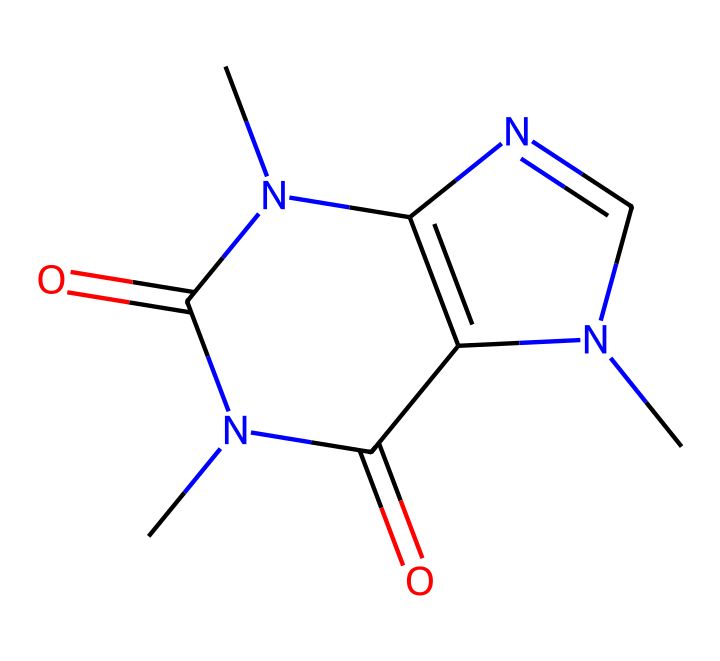What is the name of this chemical? The SMILES notation provided represents the molecular structure of caffeine. By analyzing the structure, it is clear that it fits the known characteristics of caffeine, which is a well-documented stimulant found in energy drinks.
Answer: caffeine How many nitrogen atoms are present in the structure? By examining the SMILES representation, we can count the nitrogen atoms denoted by the 'N' symbols. The structure contains four nitrogen atoms.
Answer: four What is the total number of oxygen atoms in this molecule? In the provided SMILES, the 'O' symbols indicate the presence of oxygen atoms. Counting them yields a total of two oxygen atoms.
Answer: two Is this compound acidic or basic? The presence of nitrogen atoms, especially in the context of caffeine, typically indicates basic properties, as nitrogen can accept protons. Therefore, this compound is classified as basic.
Answer: basic Does this chemical contain any double bonds? The SMILES notation includes '=' symbols, which represent double bonds between atoms in the structure. By identifying these, we can confirm that the molecule has double bonds.
Answer: yes What type of chemical class does caffeine belong to? Caffeine is classified as an alkaloid due to its nitrogen-containing structure and biochemical properties. This classification is generally based on the presence of nitrogen within a cyclic structure, characteristic of alkaloids.
Answer: alkaloid 